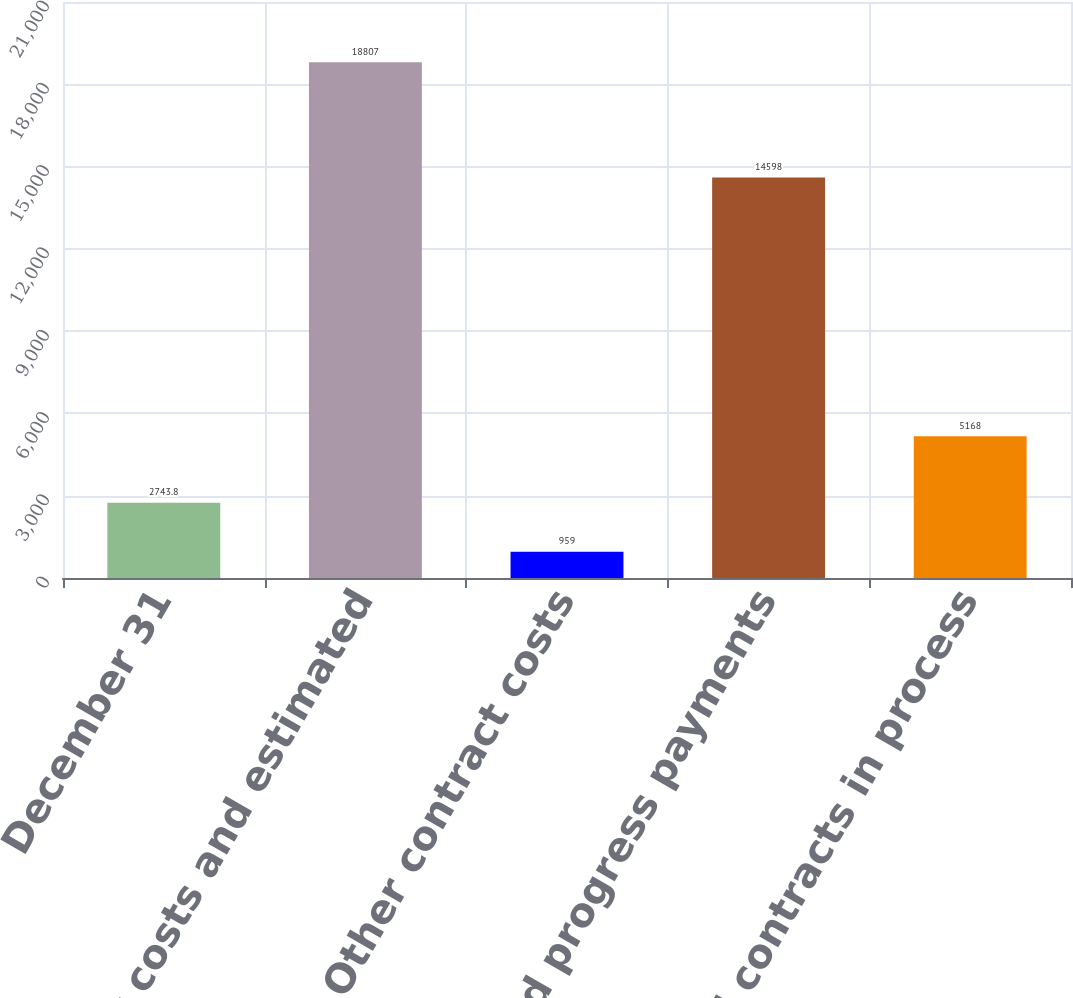<chart> <loc_0><loc_0><loc_500><loc_500><bar_chart><fcel>December 31<fcel>Contract costs and estimated<fcel>Other contract costs<fcel>Advances and progress payments<fcel>Total contracts in process<nl><fcel>2743.8<fcel>18807<fcel>959<fcel>14598<fcel>5168<nl></chart> 